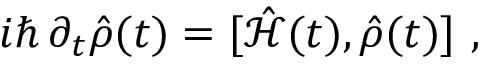<formula> <loc_0><loc_0><loc_500><loc_500>i \hslash \, \partial _ { t } \hat { \rho } ( t ) = [ \hat { \mathcal { H } } ( t ) , \hat { \rho } ( t ) ] ,</formula> 